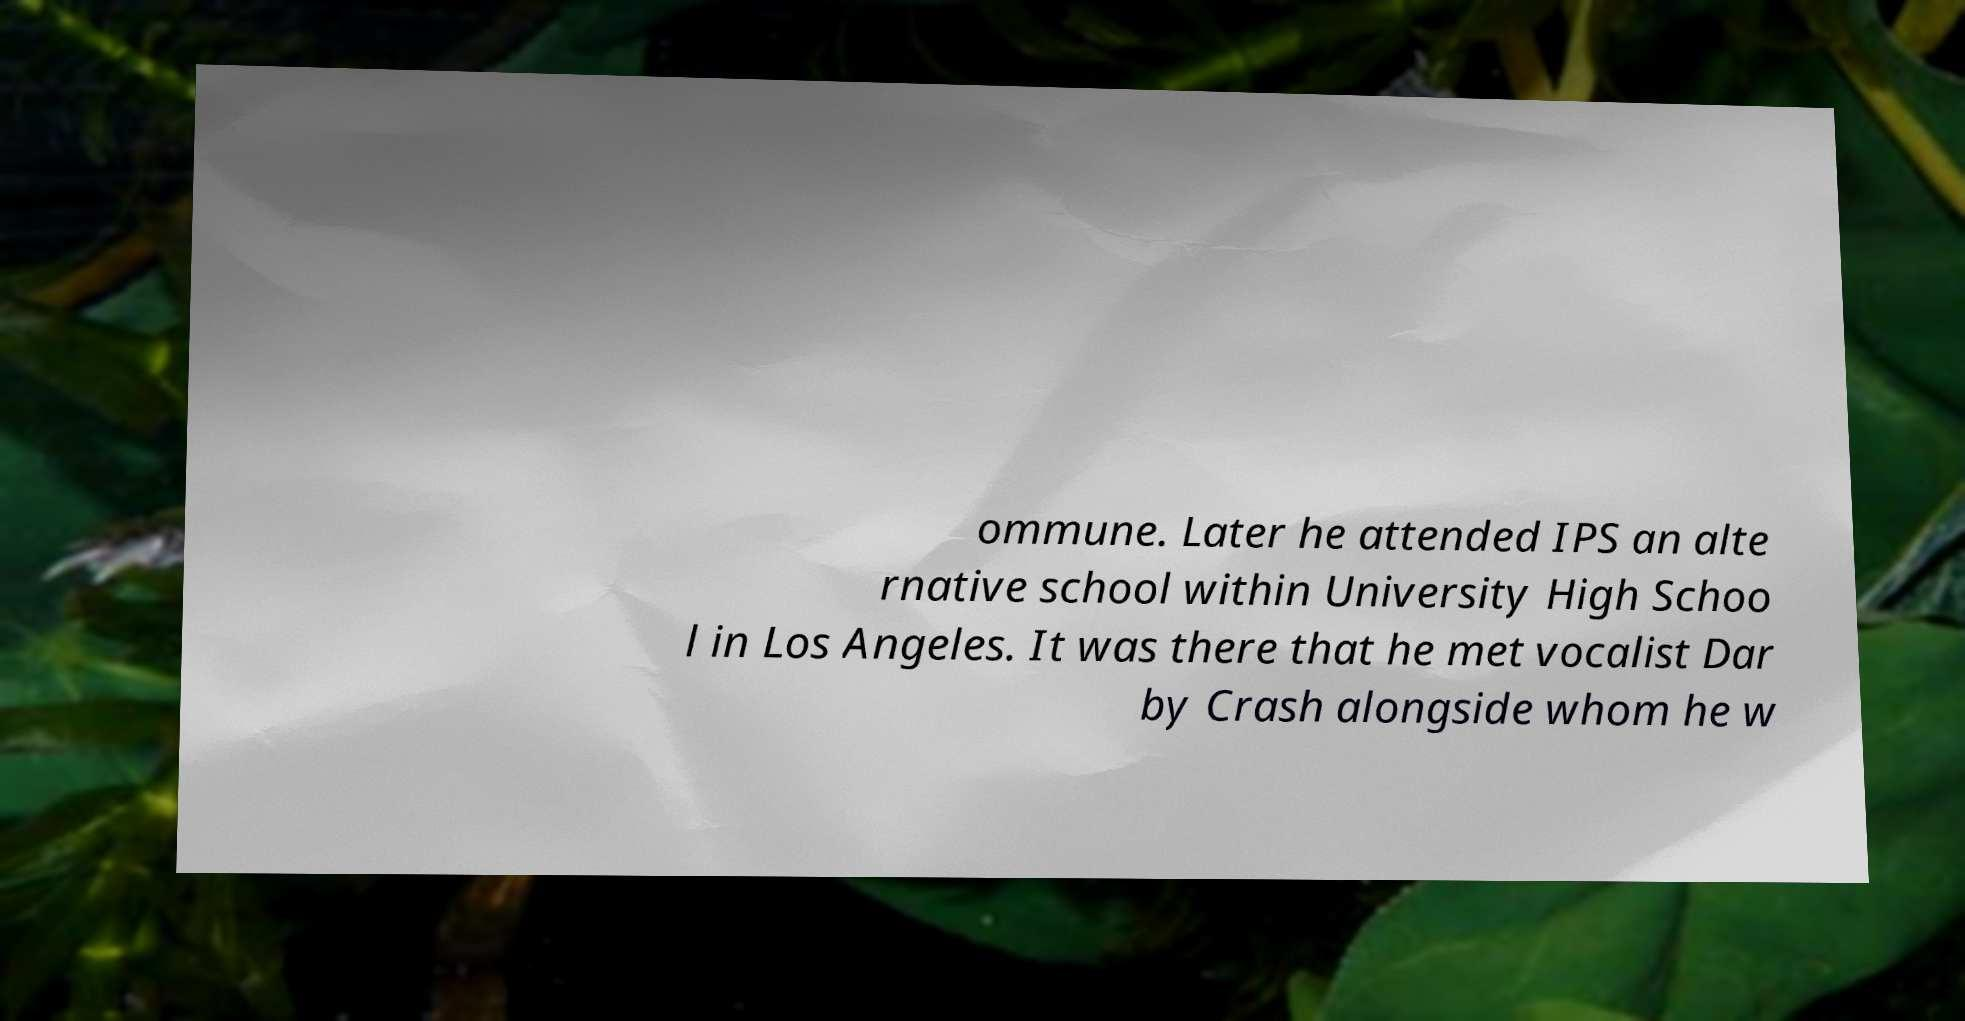For documentation purposes, I need the text within this image transcribed. Could you provide that? ommune. Later he attended IPS an alte rnative school within University High Schoo l in Los Angeles. It was there that he met vocalist Dar by Crash alongside whom he w 